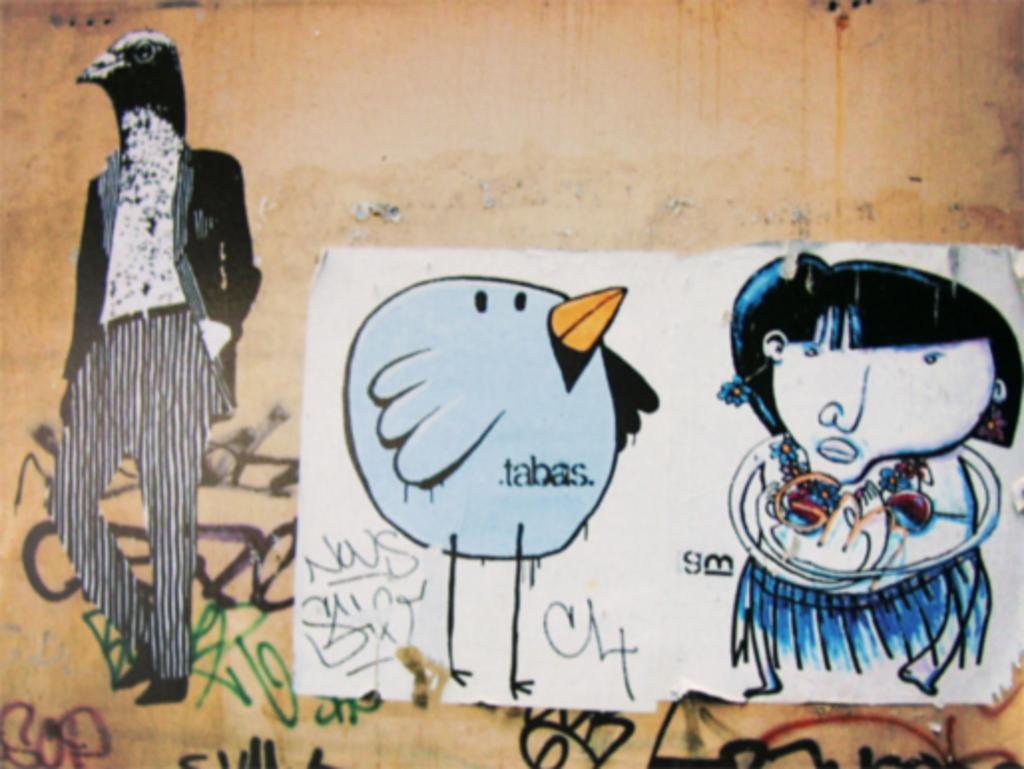What is on the wall in the image? There is a painting on the wall in the image. What is depicted in the painting? The painting depicts a girl and a bird, as well as a person with an eagle head. What else can be found in the image besides the painting? There is text present in the image. What shape is the kick in the image? There is no kick present in the image; it is a painting of a girl, a bird, and a person with an eagle head. 